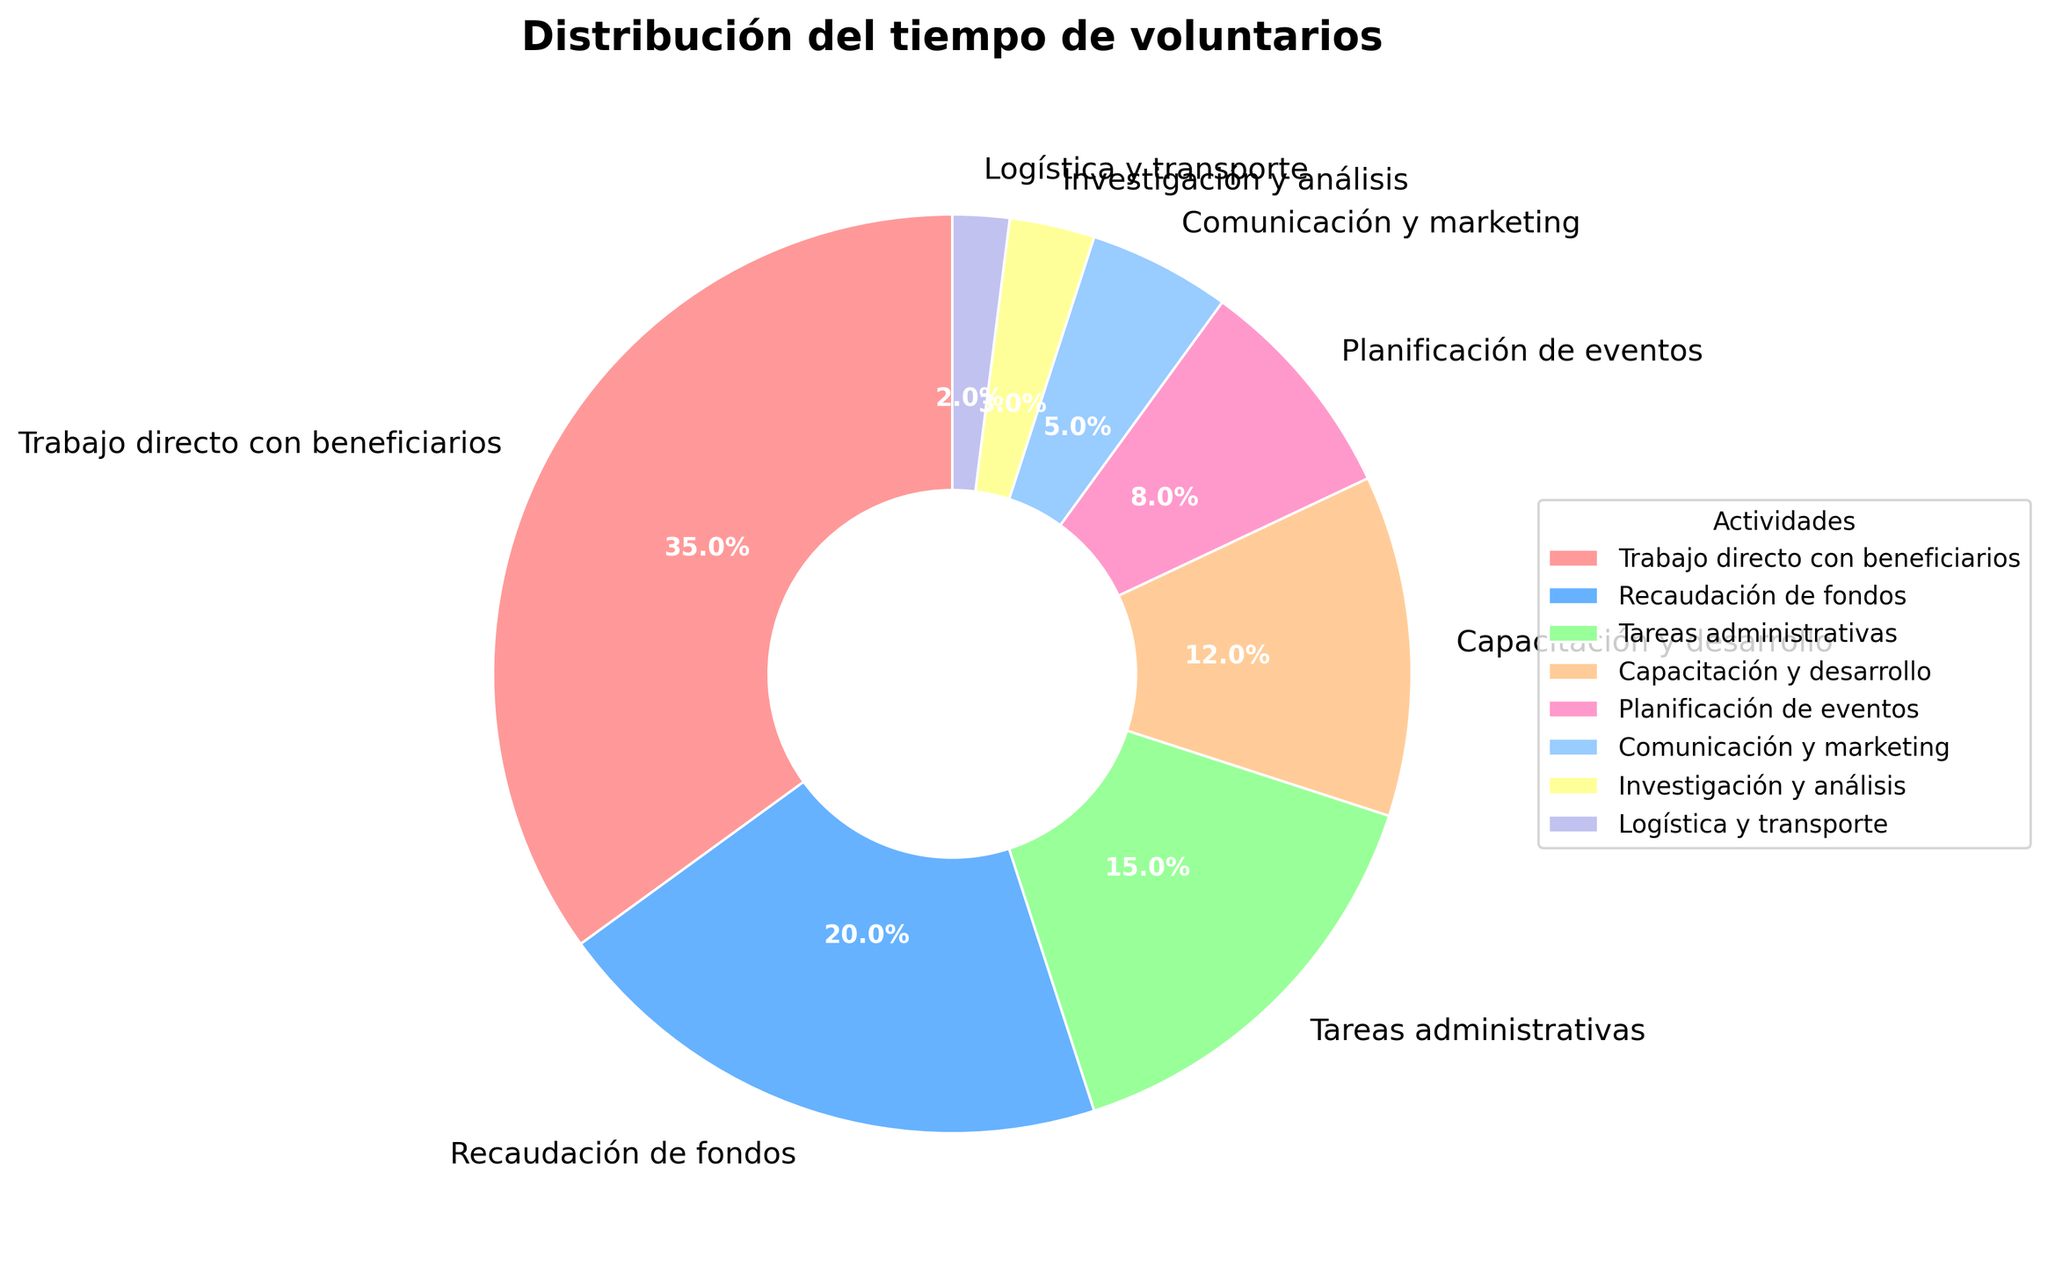What's the largest segment of the pie chart? The largest segment can be identified by looking at the percentage values on the pie chart. The one with the highest percentage is "Trabajo directo con beneficiarios" at 35%.
Answer: Trabajo directo con beneficiarios Which activity takes the least amount of volunteer time? The smallest segment of the pie chart represents the activity that consumes the least amount of volunteer time. In this case, it's "Logística y transporte" with 2%.
Answer: Logística y transporte What is the total percentage of time spent on "Capacitación y desarrollo" and "Planificación de eventos"? To find this, add the percentages for both activities: "Capacitación y desarrollo" (12%) and "Planificación de eventos" (8%). The total is 12% + 8% = 20%.
Answer: 20% Which activities combined take up more than half of the total volunteer time? To answer this, identify the activities whose percentages sum up to more than 50%. "Trabajo directo con beneficiarios" (35%) + "Recaudación de fondos" (20%) = 55%. So these two activities combined take up more than 50% of the time.
Answer: Trabajo directo con beneficiarios and Recaudación de fondos Compare the time spent on "Trabajo directo con beneficiarios" and "Recaudación de fondos". Which one is higher and by how much? "Trabajo directo con beneficiarios" has 35% and "Recaudación de fondos" has 20%. The difference is 35% - 20% = 15%. So, "Trabajo directo con beneficiarios" is higher by 15%.
Answer: Trabajo directo con beneficiarios by 15% What is the average percentage of time spent on "Tareas administrativas", "Capacitación y desarrollo", and "Planificación de eventos"? Add the percentages and divide by the number of activities: (15% + 12% + 8%) / 3 = 35% / 3 ≈ 11.67%.
Answer: 11.67% Which activity segment is represented by a purple color? By looking at the colors in the pie chart, the purple segment represents "Recaudación de fondos".
Answer: Recaudación de fondos Is the time spent on "Comunicación y marketing" more than or less than 10%? The pie chart shows that "Comunicación y marketing" occupies 5%, which is less than 10%.
Answer: Less than 10% 